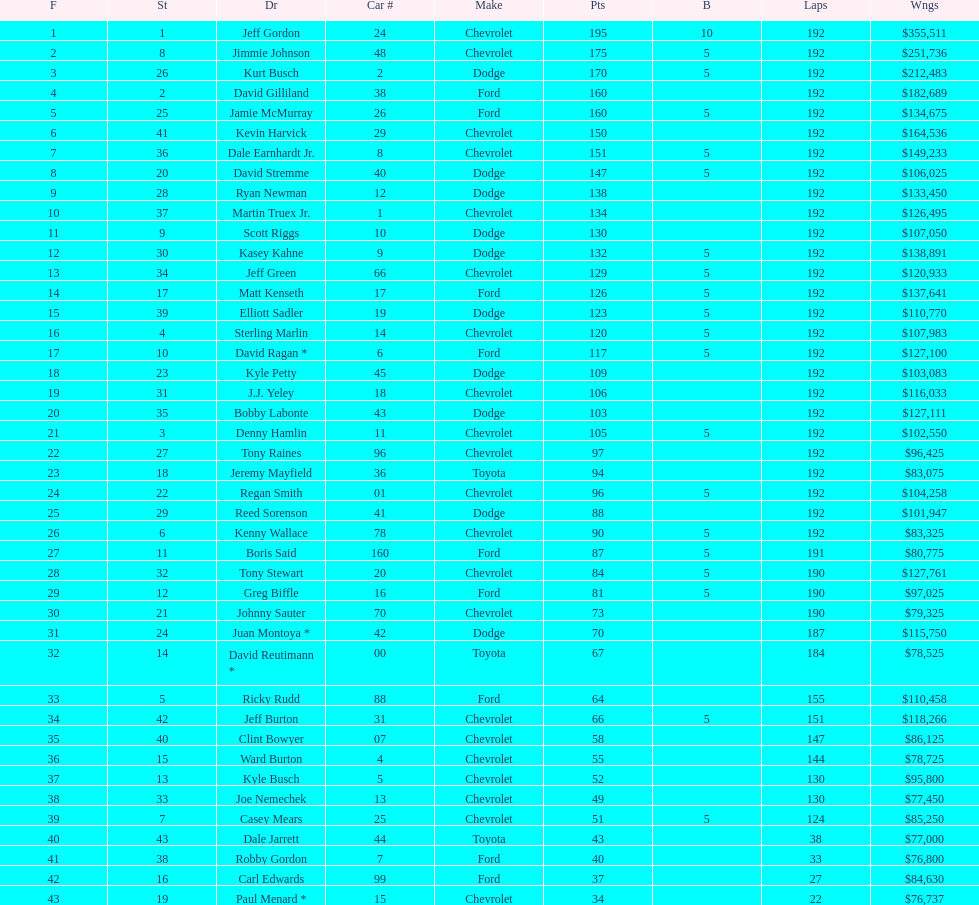Who got the most bonus points? Jeff Gordon. 